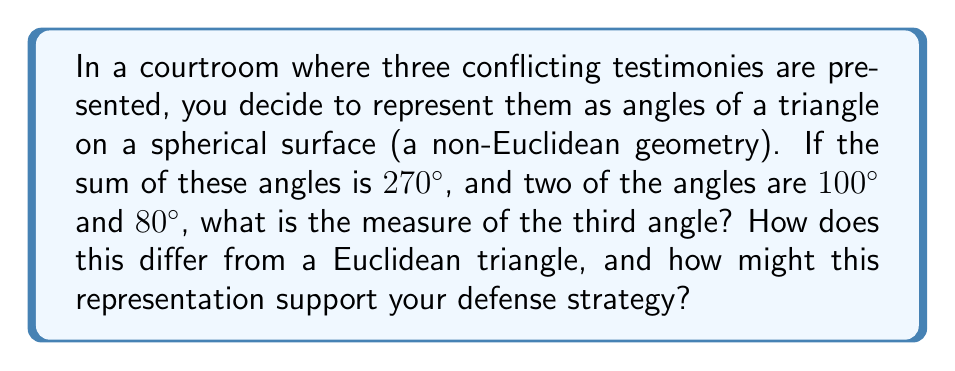Teach me how to tackle this problem. Let's approach this step-by-step:

1) In spherical geometry, the sum of angles in a triangle is always greater than 180°. This excess is called the spherical excess, denoted by $E$.

2) The formula for spherical excess is:
   $$E = (A + B + C) - 180°$$
   where $A$, $B$, and $C$ are the angles of the spherical triangle.

3) We're given that the sum of the angles is 270°, so:
   $$270° = A + B + C$$

4) We know two of the angles: 100° and 80°. Let's call the unknown angle $x$. So:
   $$270° = 100° + 80° + x$$

5) Solving for $x$:
   $$x = 270° - 100° - 80° = 90°$$

6) In a Euclidean triangle, the sum of angles is always 180°. Here, it's 270°, which is 90° more.

7) This representation could support a defense strategy by illustrating that:
   a) The testimonies, while conflicting, all contribute to a larger truth (the whole triangle).
   b) The "excess" angle sum (270° vs 180°) could represent additional context or complexity in the case.
   c) Just as spherical geometry requires a different perspective than planar geometry, this case might require thinking beyond conventional viewpoints.
Answer: 90°; Spherical excess of 90° compared to Euclidean triangle; Represents complexity and interconnectedness of testimonies. 